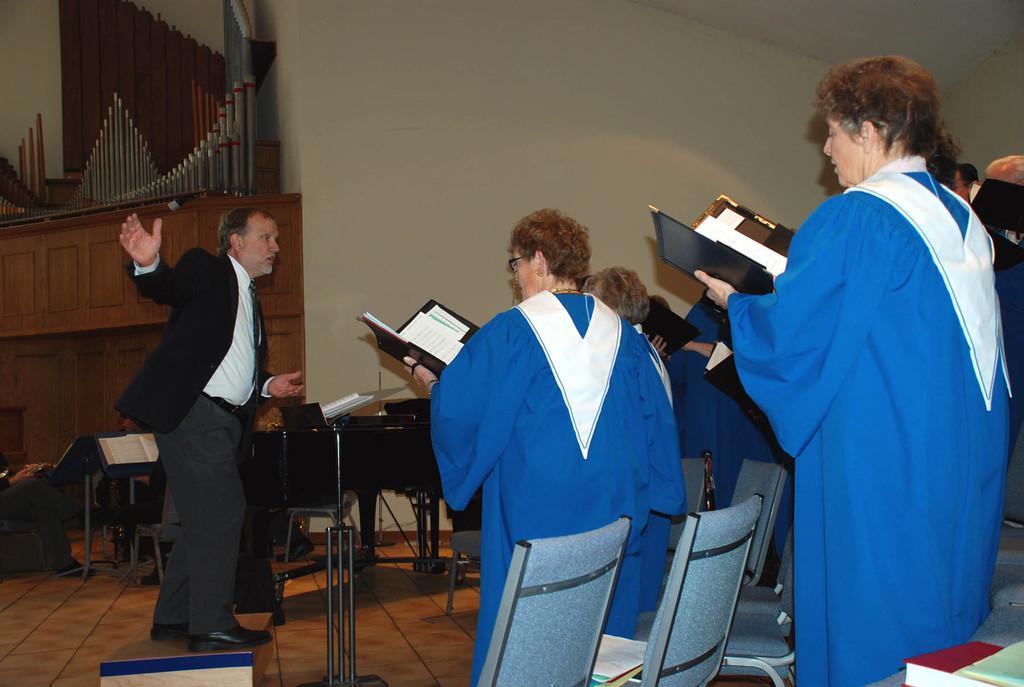Could you give a brief overview of what you see in this image? This is an inside view. On the right side there are few people wearing blue color coats, holding books in their hands and standing facing towards the left side. On the left side there is a man standing and speaking by looking at these people. In front of him there is a table and few metal stands. At the back of him there are few objects placed on the floor. At the bottom there are few empty chairs. In the background there is an object which is made up of wood and a wall. 